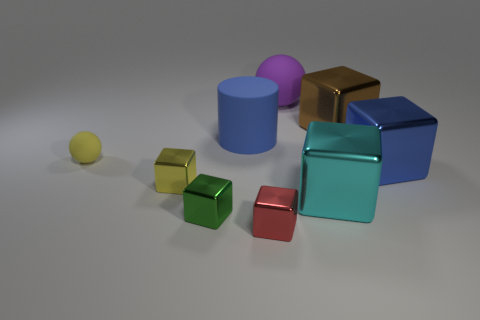Are there any other things that have the same shape as the large blue rubber thing? The large blue object in the image is cylindrical. There are no other objects in the image with exactly the same cylindrical shape, but there are objects with similar geometric qualities such as the smaller cylinders and cubes, suggestive of a playful exploration of shapes and sizes. 